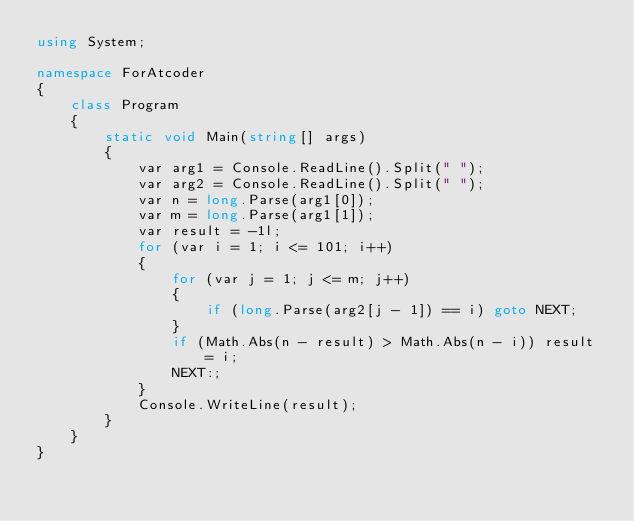Convert code to text. <code><loc_0><loc_0><loc_500><loc_500><_C#_>using System;

namespace ForAtcoder
{
    class Program
    {
        static void Main(string[] args)
        {
            var arg1 = Console.ReadLine().Split(" ");
            var arg2 = Console.ReadLine().Split(" ");
            var n = long.Parse(arg1[0]);
            var m = long.Parse(arg1[1]);
            var result = -1l;
            for (var i = 1; i <= 101; i++)
            {
                for (var j = 1; j <= m; j++)
                {
                    if (long.Parse(arg2[j - 1]) == i) goto NEXT;
                }
                if (Math.Abs(n - result) > Math.Abs(n - i)) result = i;
                NEXT:;
            }
            Console.WriteLine(result);
        }
    }
}</code> 